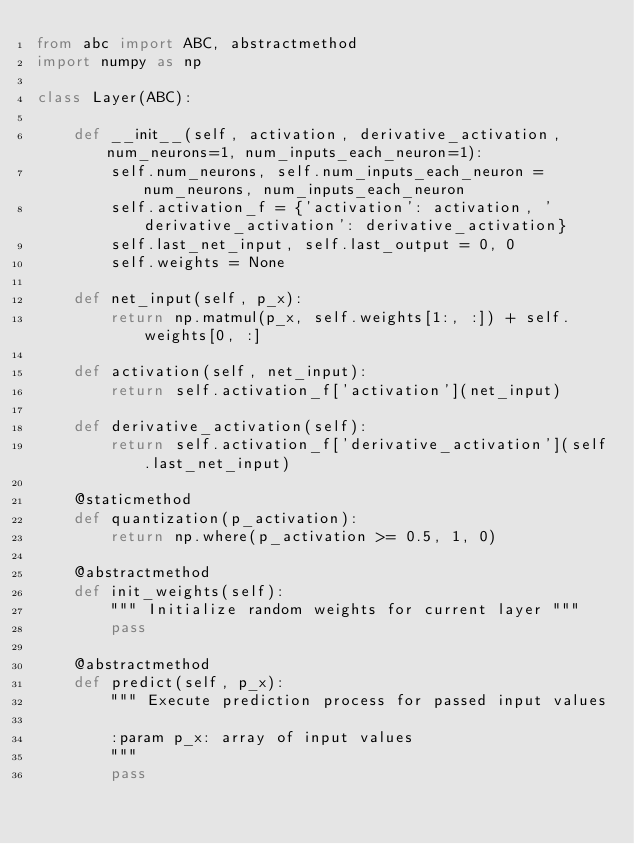Convert code to text. <code><loc_0><loc_0><loc_500><loc_500><_Python_>from abc import ABC, abstractmethod
import numpy as np

class Layer(ABC):

    def __init__(self, activation, derivative_activation, num_neurons=1, num_inputs_each_neuron=1):
        self.num_neurons, self.num_inputs_each_neuron = num_neurons, num_inputs_each_neuron
        self.activation_f = {'activation': activation, 'derivative_activation': derivative_activation}
        self.last_net_input, self.last_output = 0, 0
        self.weights = None

    def net_input(self, p_x):
        return np.matmul(p_x, self.weights[1:, :]) + self.weights[0, :]

    def activation(self, net_input):
        return self.activation_f['activation'](net_input)

    def derivative_activation(self):
        return self.activation_f['derivative_activation'](self.last_net_input)

    @staticmethod
    def quantization(p_activation):
        return np.where(p_activation >= 0.5, 1, 0)

    @abstractmethod
    def init_weights(self):
        """ Initialize random weights for current layer """
        pass

    @abstractmethod
    def predict(self, p_x):
        """ Execute prediction process for passed input values

        :param p_x: array of input values
        """
        pass
</code> 